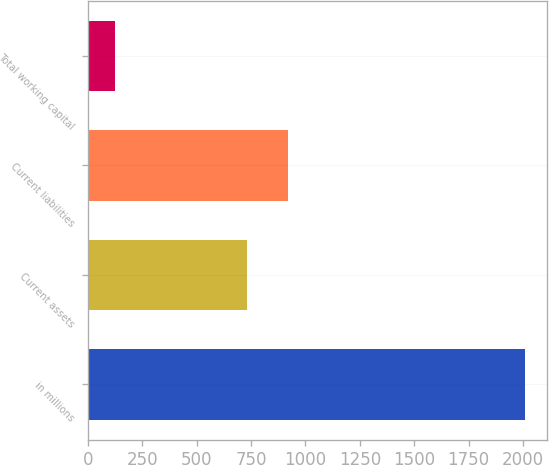Convert chart. <chart><loc_0><loc_0><loc_500><loc_500><bar_chart><fcel>in millions<fcel>Current assets<fcel>Current liabilities<fcel>Total working capital<nl><fcel>2009<fcel>732.9<fcel>921.42<fcel>123.8<nl></chart> 